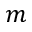<formula> <loc_0><loc_0><loc_500><loc_500>m</formula> 